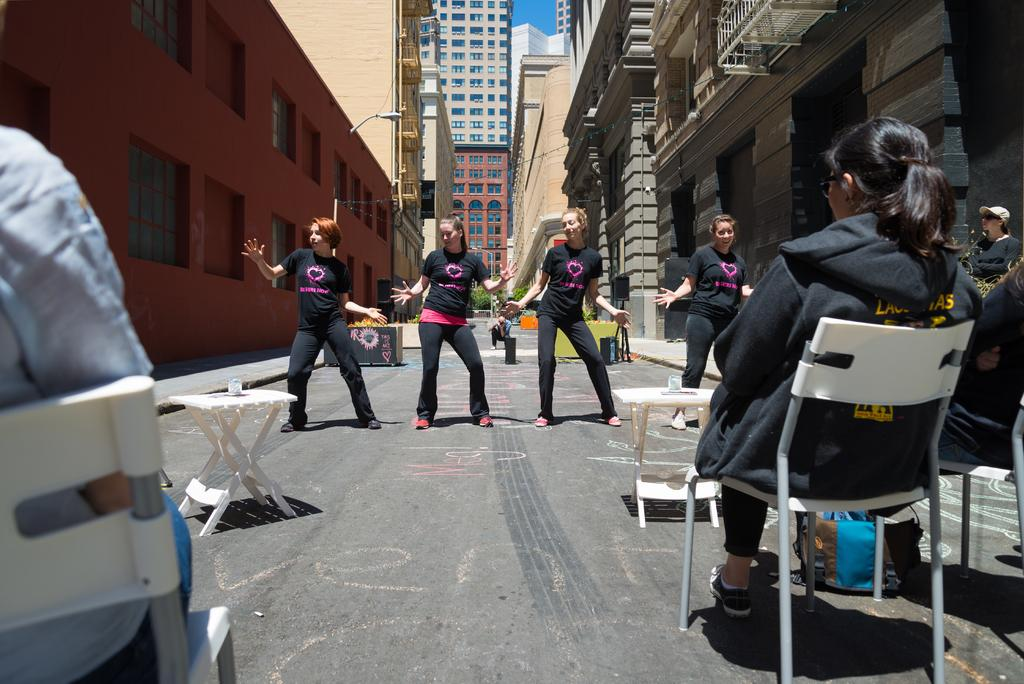What are the four people in the image doing? The four people in the image are dancing. What are the other people in the image doing? The other people in the image are sitting. How are the people sitting positioned in the image? The people sitting are on chairs. What can be seen in the background of the image? There are buildings visible in the image. What type of silk is being used to enhance the acoustics in the image? There is no mention of silk or acoustics in the image, as it primarily features people dancing and sitting. 